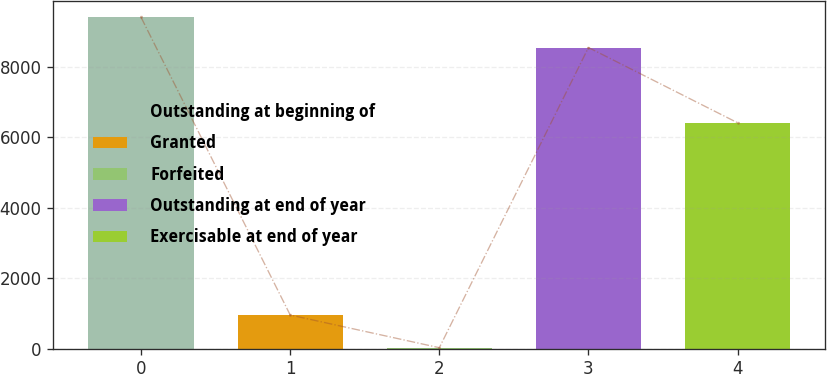Convert chart to OTSL. <chart><loc_0><loc_0><loc_500><loc_500><bar_chart><fcel>Outstanding at beginning of<fcel>Granted<fcel>Forfeited<fcel>Outstanding at end of year<fcel>Exercisable at end of year<nl><fcel>9412.2<fcel>955<fcel>26<fcel>8555<fcel>6417<nl></chart> 